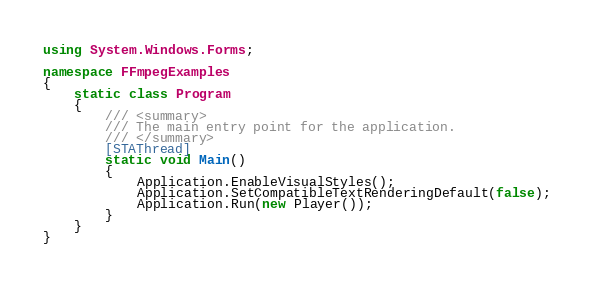<code> <loc_0><loc_0><loc_500><loc_500><_C#_>using System.Windows.Forms;

namespace FFmpegExamples
{
    static class Program
    {
        /// <summary>
        /// The main entry point for the application.
        /// </summary>
        [STAThread]
        static void Main()
        {
            Application.EnableVisualStyles();
            Application.SetCompatibleTextRenderingDefault(false);
            Application.Run(new Player());
        }
    }
}</code> 